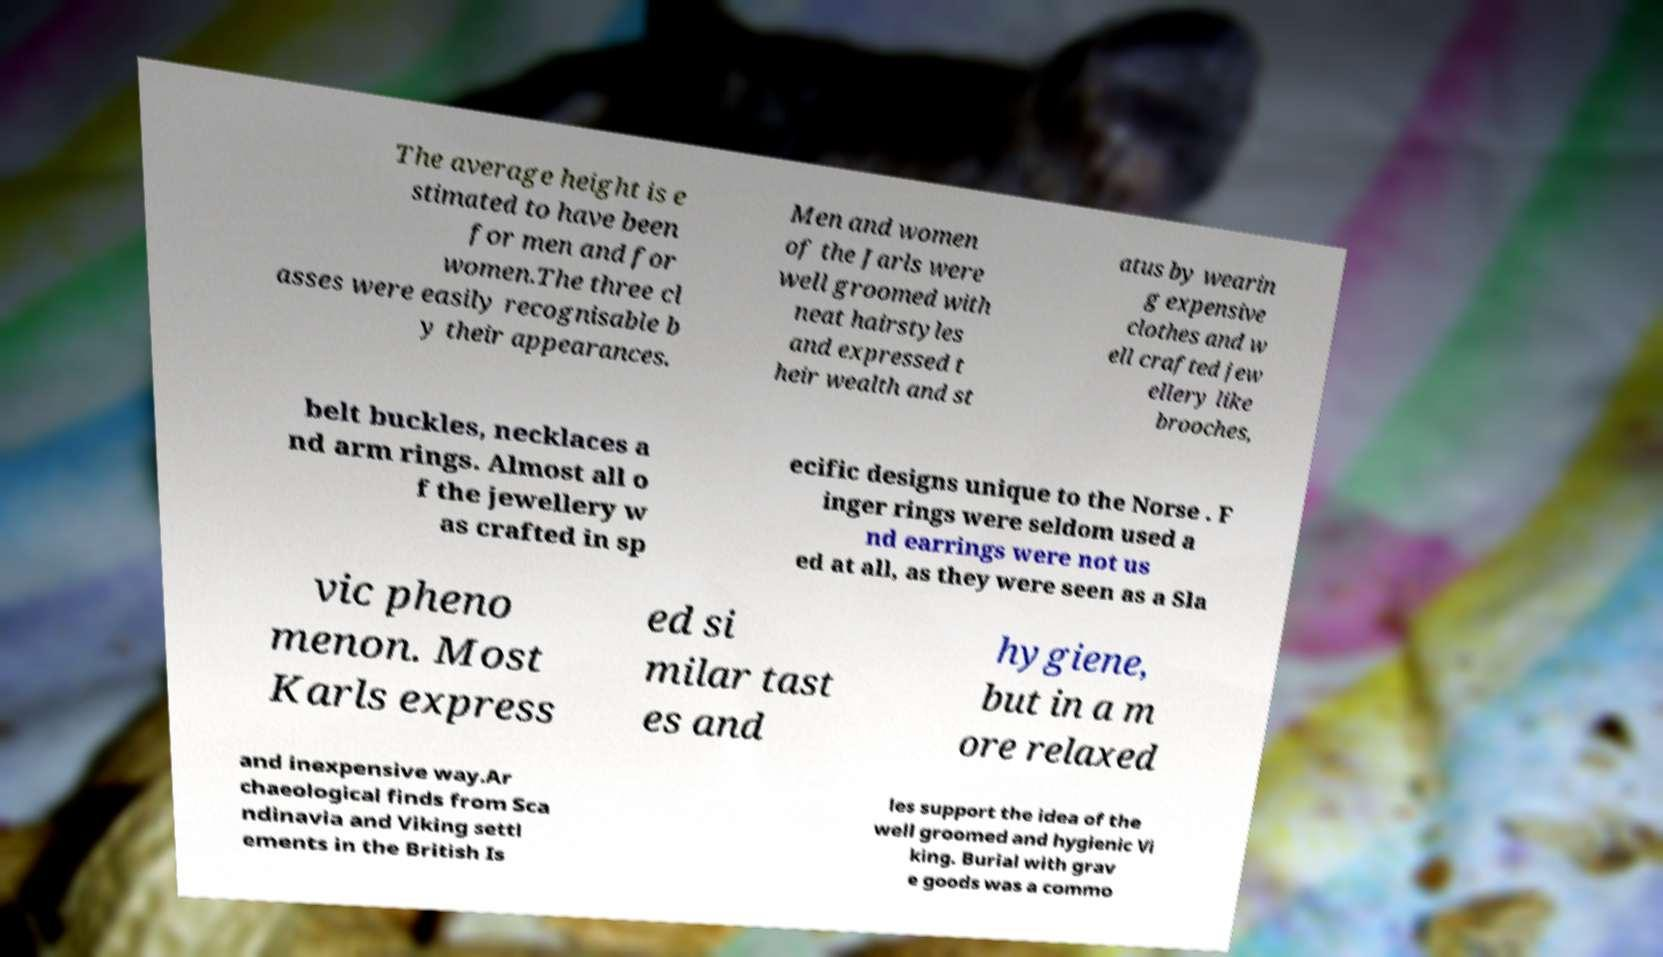What messages or text are displayed in this image? I need them in a readable, typed format. The average height is e stimated to have been for men and for women.The three cl asses were easily recognisable b y their appearances. Men and women of the Jarls were well groomed with neat hairstyles and expressed t heir wealth and st atus by wearin g expensive clothes and w ell crafted jew ellery like brooches, belt buckles, necklaces a nd arm rings. Almost all o f the jewellery w as crafted in sp ecific designs unique to the Norse . F inger rings were seldom used a nd earrings were not us ed at all, as they were seen as a Sla vic pheno menon. Most Karls express ed si milar tast es and hygiene, but in a m ore relaxed and inexpensive way.Ar chaeological finds from Sca ndinavia and Viking settl ements in the British Is les support the idea of the well groomed and hygienic Vi king. Burial with grav e goods was a commo 